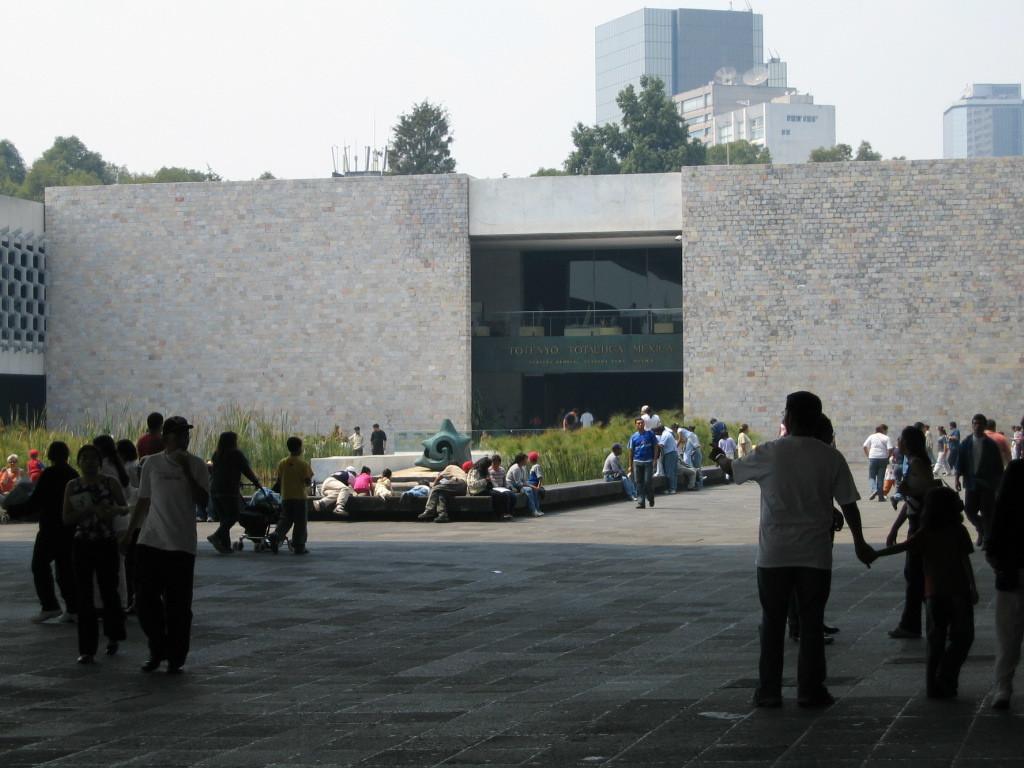How would you summarize this image in a sentence or two? In this picture we can see the group of men and women waiting in the ground. Behind there is a big brick wall. In the background we can see some trees and buildings. 